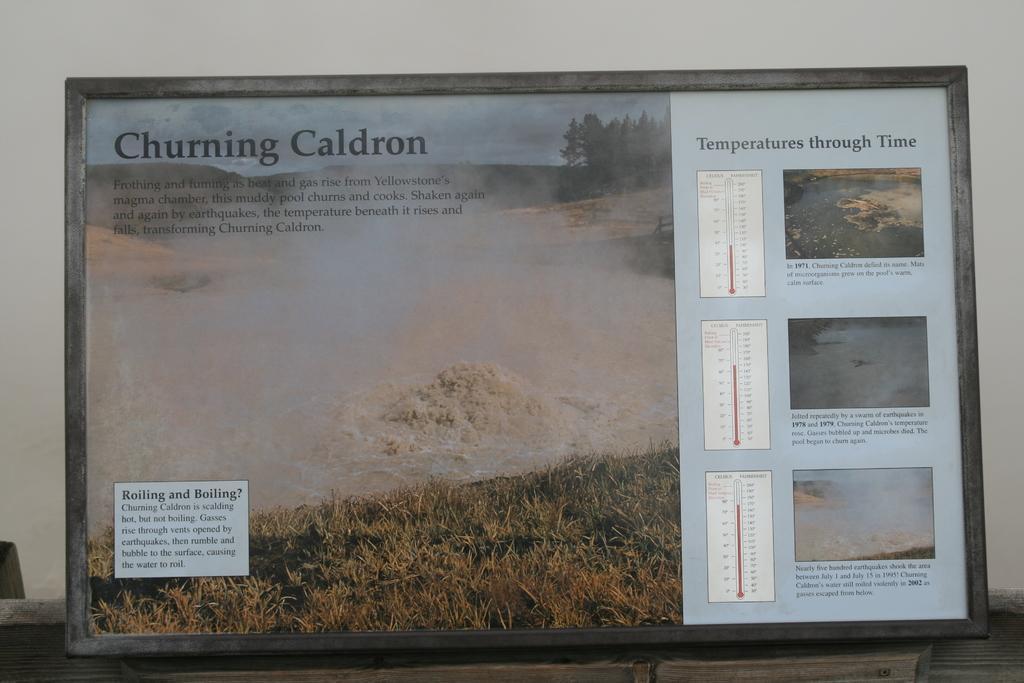Could you give a brief overview of what you see in this image? In this picture we can see a frame on a platform and on this frame we can see the grass, water, trees, thermometers, sky and some text and in the background we can see the wall. 